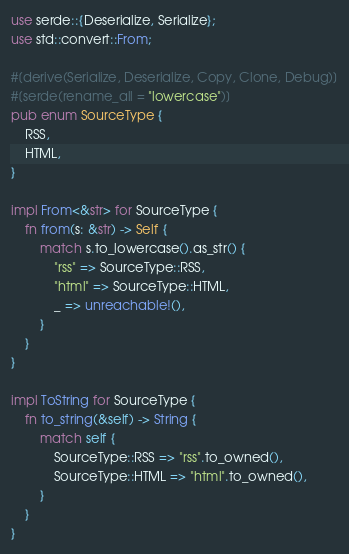<code> <loc_0><loc_0><loc_500><loc_500><_Rust_>use serde::{Deserialize, Serialize};
use std::convert::From;

#[derive(Serialize, Deserialize, Copy, Clone, Debug)]
#[serde(rename_all = "lowercase")]
pub enum SourceType {
    RSS,
    HTML,
}

impl From<&str> for SourceType {
    fn from(s: &str) -> Self {
        match s.to_lowercase().as_str() {
            "rss" => SourceType::RSS,
            "html" => SourceType::HTML,
            _ => unreachable!(),
        }
    }
}

impl ToString for SourceType {
    fn to_string(&self) -> String {
        match self {
            SourceType::RSS => "rss".to_owned(),
            SourceType::HTML => "html".to_owned(),
        }
    }
}
</code> 